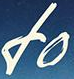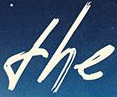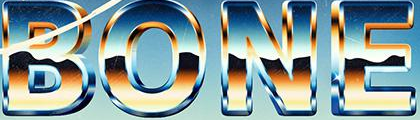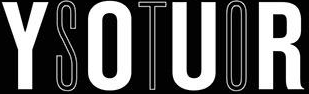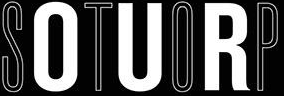Read the text from these images in sequence, separated by a semicolon. fo; the; BONE; YOUR; STOP 